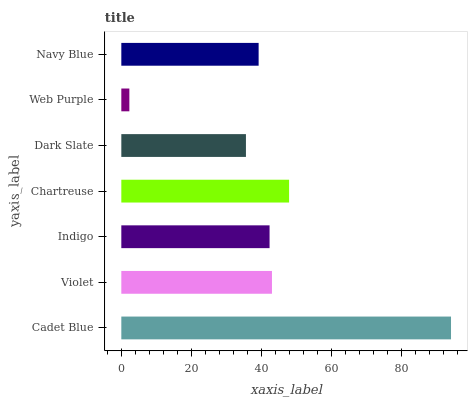Is Web Purple the minimum?
Answer yes or no. Yes. Is Cadet Blue the maximum?
Answer yes or no. Yes. Is Violet the minimum?
Answer yes or no. No. Is Violet the maximum?
Answer yes or no. No. Is Cadet Blue greater than Violet?
Answer yes or no. Yes. Is Violet less than Cadet Blue?
Answer yes or no. Yes. Is Violet greater than Cadet Blue?
Answer yes or no. No. Is Cadet Blue less than Violet?
Answer yes or no. No. Is Indigo the high median?
Answer yes or no. Yes. Is Indigo the low median?
Answer yes or no. Yes. Is Violet the high median?
Answer yes or no. No. Is Cadet Blue the low median?
Answer yes or no. No. 